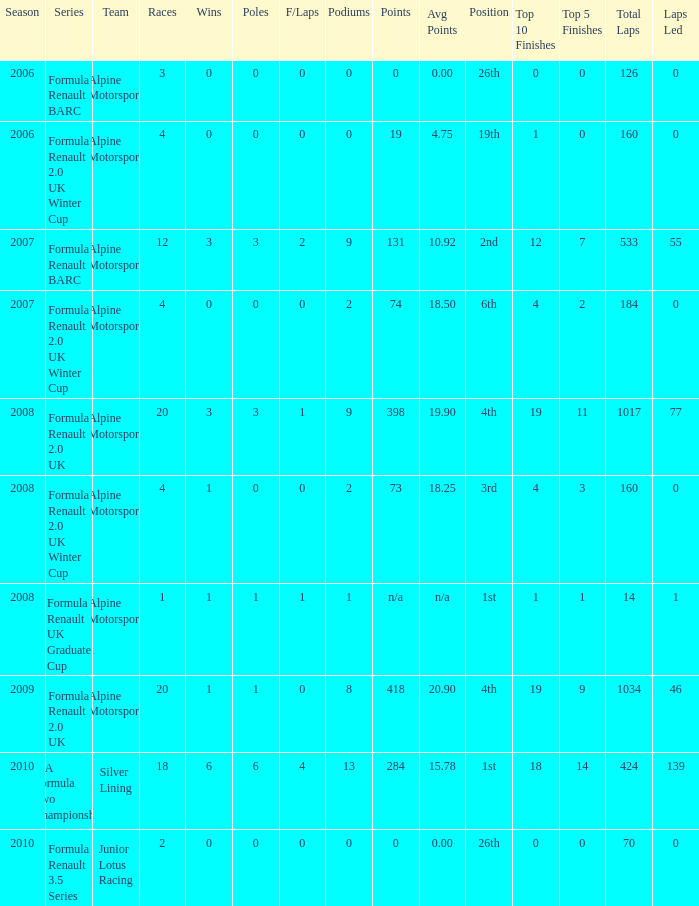What competitions reached 0 f/laps and 1 pole position? 20.0. 